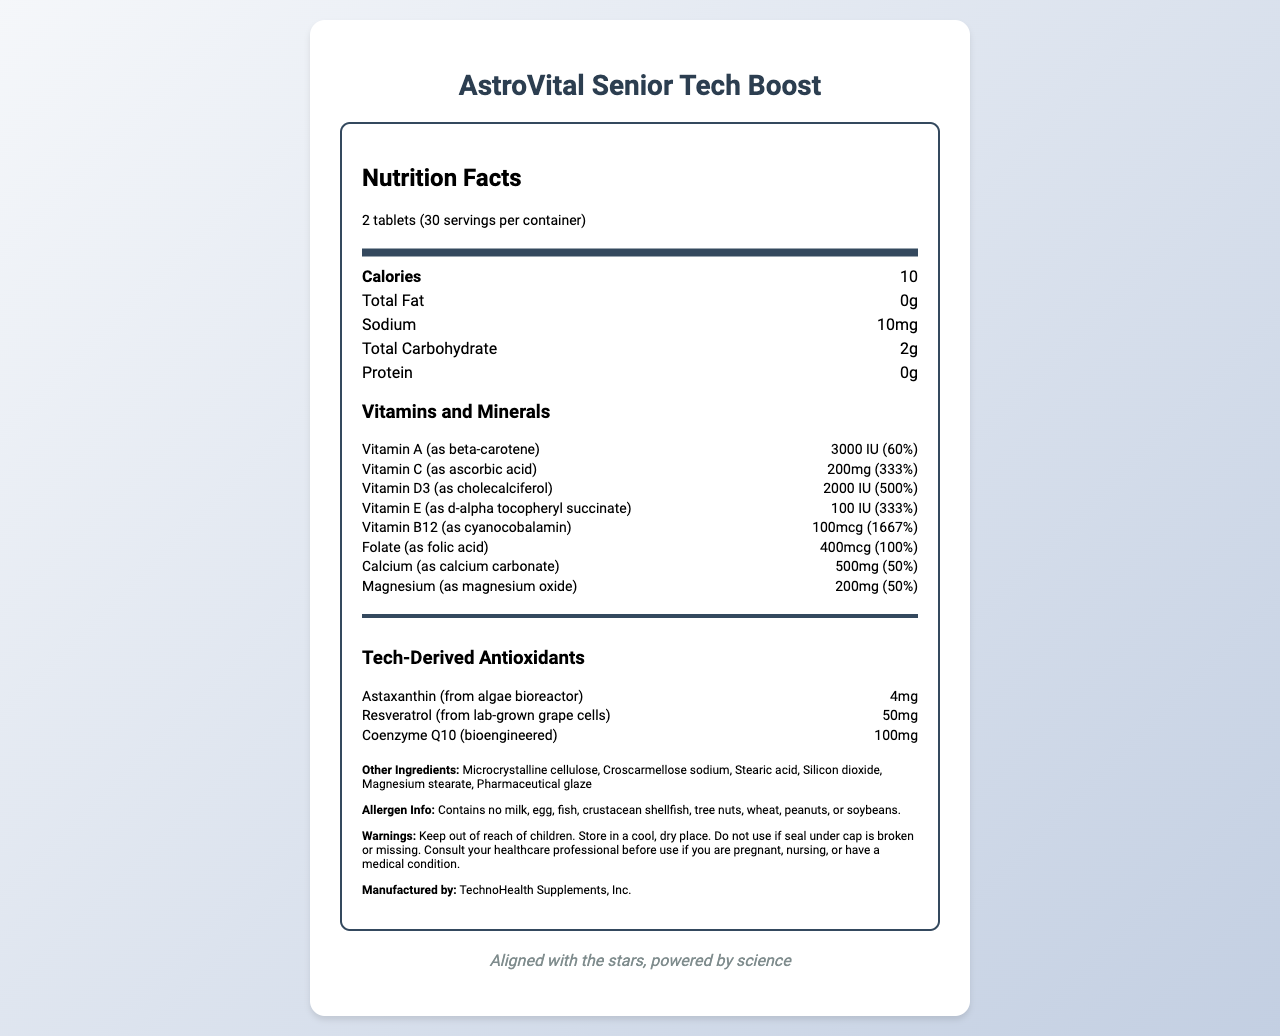what is the serving size? The serving size is mentioned under the "Nutrition Facts" section as "2 tablets."
Answer: 2 tablets how many calories are in a serving? The calorie content is listed under "Calories" in the Nutrition Facts section.
Answer: 10 calories what is the percentage daily value of Vitamin D3? The percentage daily value for Vitamin D3 is noted to be 500%.
Answer: 500% what are the total carbohydrates in a serving? The total carbohydrates are listed as "2g" in the Nutrient section of the label.
Answer: 2g how much Vitamin B12 does each serving contain? The amount of Vitamin B12 per serving is listed as "100mcg."
Answer: 100mcg what company manufactures this supplement? The manufacturer is listed as "TechnoHealth Supplements, Inc."
Answer: TechnoHealth Supplements, Inc. what allergens does this product contain? The allergen info specifies that the product contains no milk, egg, fish, crustacean shellfish, tree nuts, wheat, peanuts, or soybeans.
Answer: Contains no milk, egg, fish, crustacean shellfish, tree nuts, wheat, peanuts, or soybeans. what are the warnings associated with this product? The label contains a series of warnings listed under "Warnings."
Answer: Keep out of reach of children. Store in a cool, dry place. Do not use if seal under cap is broken or missing. Consult your healthcare professional before use if you are pregnant, nursing, or have a medical condition. which of the following vitamins is present in the highest daily value percentage? A. Vitamin A B. Vitamin C C. Vitamin E D. Vitamin B12 Vitamin B12 has a daily value percentage of 1667%, which is the highest among the listed options.
Answer: D how many servings are in one container? A. 20 B. 25 C. 30 D. 40 The number of servings per container is listed as "30."
Answer: C does the product contain any protein? The Nutrition Facts section lists the protein content as "0g."
Answer: No summarize the main idea of the document. The document focuses on listing the nutritional benefits, ingredients, and warnings related to the supplement, emphasizing its suitability for seniors and its inclusion of tech-derived antioxidants.
Answer: The document provides the nutritional information for a senior-friendly multivitamin supplement named "AstroVital Senior Tech Boost." It includes details about the serving size, calorie content, vitamins, minerals, tech-derived antioxidants, other ingredients, allergen information, warnings, and the manufacturing company. what is the amount of Resveratrol in each serving, and what is its daily value percentage? The document specifies that Resveratrol is included in each serving at 50mg, but it does not provide a daily value percentage for this ingredient.
Answer: Not enough information 